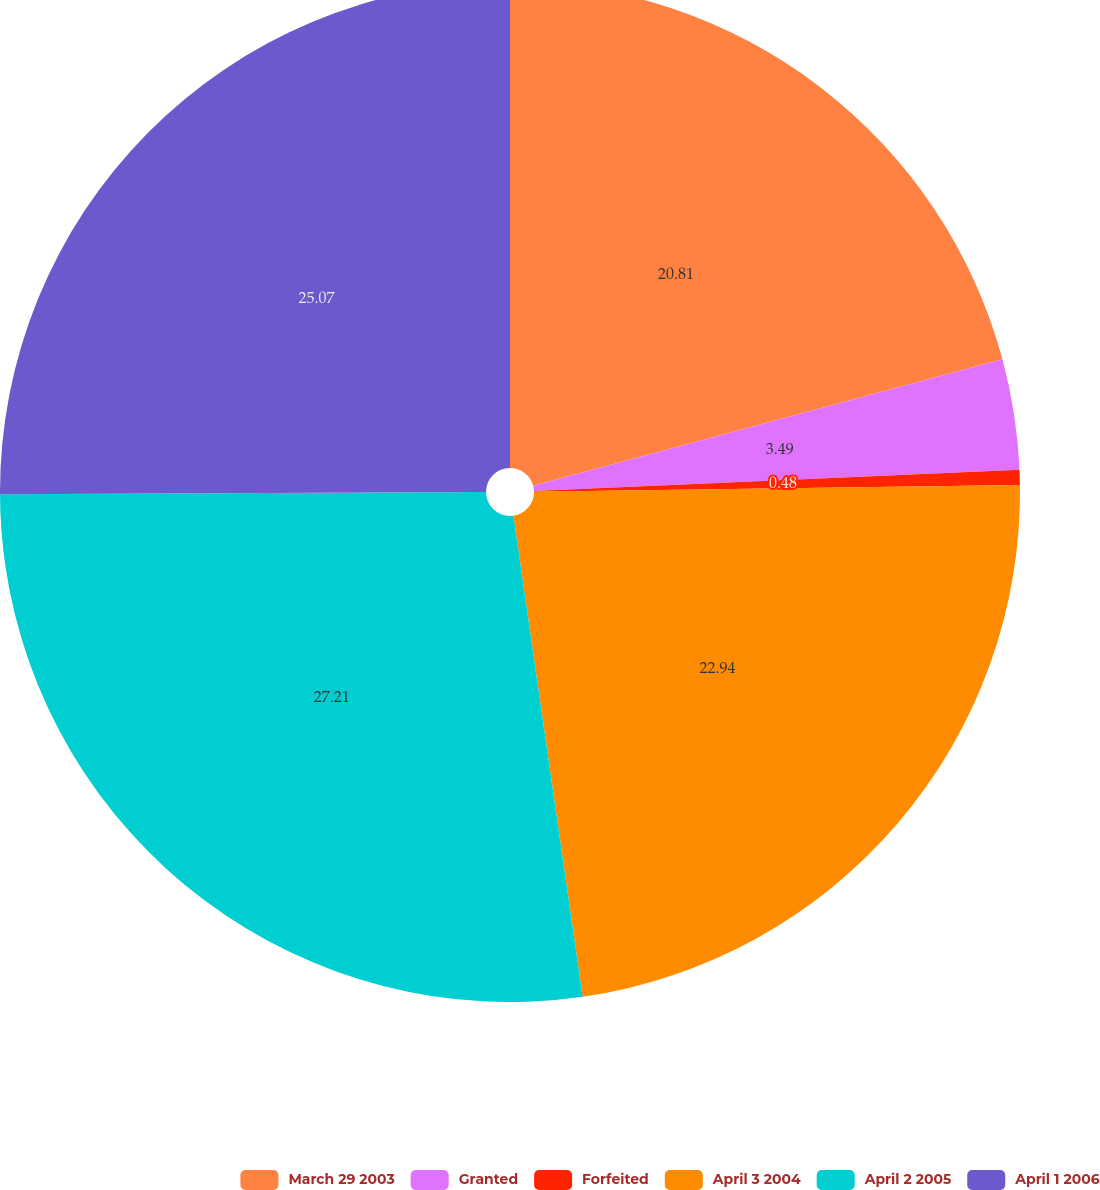Convert chart to OTSL. <chart><loc_0><loc_0><loc_500><loc_500><pie_chart><fcel>March 29 2003<fcel>Granted<fcel>Forfeited<fcel>April 3 2004<fcel>April 2 2005<fcel>April 1 2006<nl><fcel>20.81%<fcel>3.49%<fcel>0.48%<fcel>22.94%<fcel>27.2%<fcel>25.07%<nl></chart> 